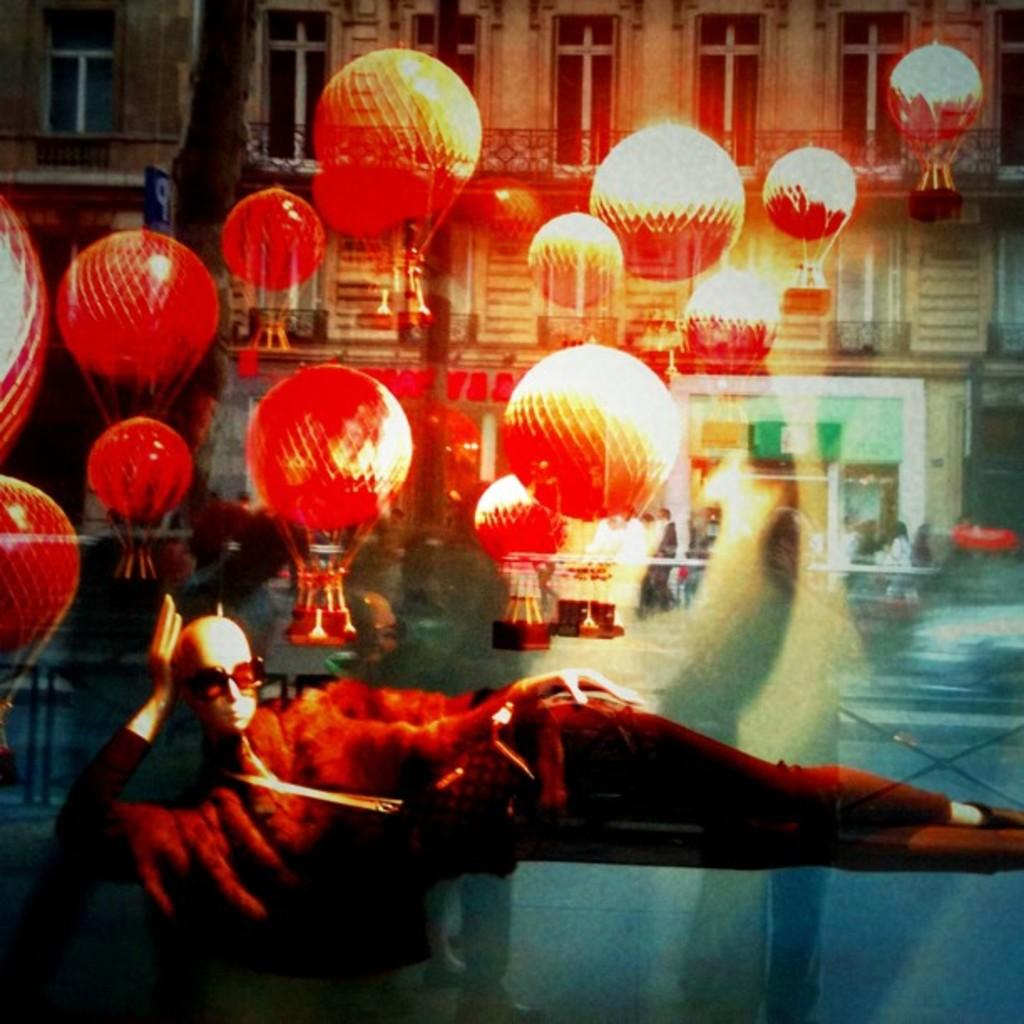What objects are floating in the image? There are balloons in the image. What else can be seen in the image besides balloons? There are lights visible in the image. What can be seen in the distance in the image? There are buildings in the background of the image. What is lying on the floor at the bottom of the image? There is a mannequin lying on the floor at the bottom of the image. What type of pet can be seen watching the mannequin in the image? There is no pet visible in the image, and the mannequin is not being watched by any animal. 